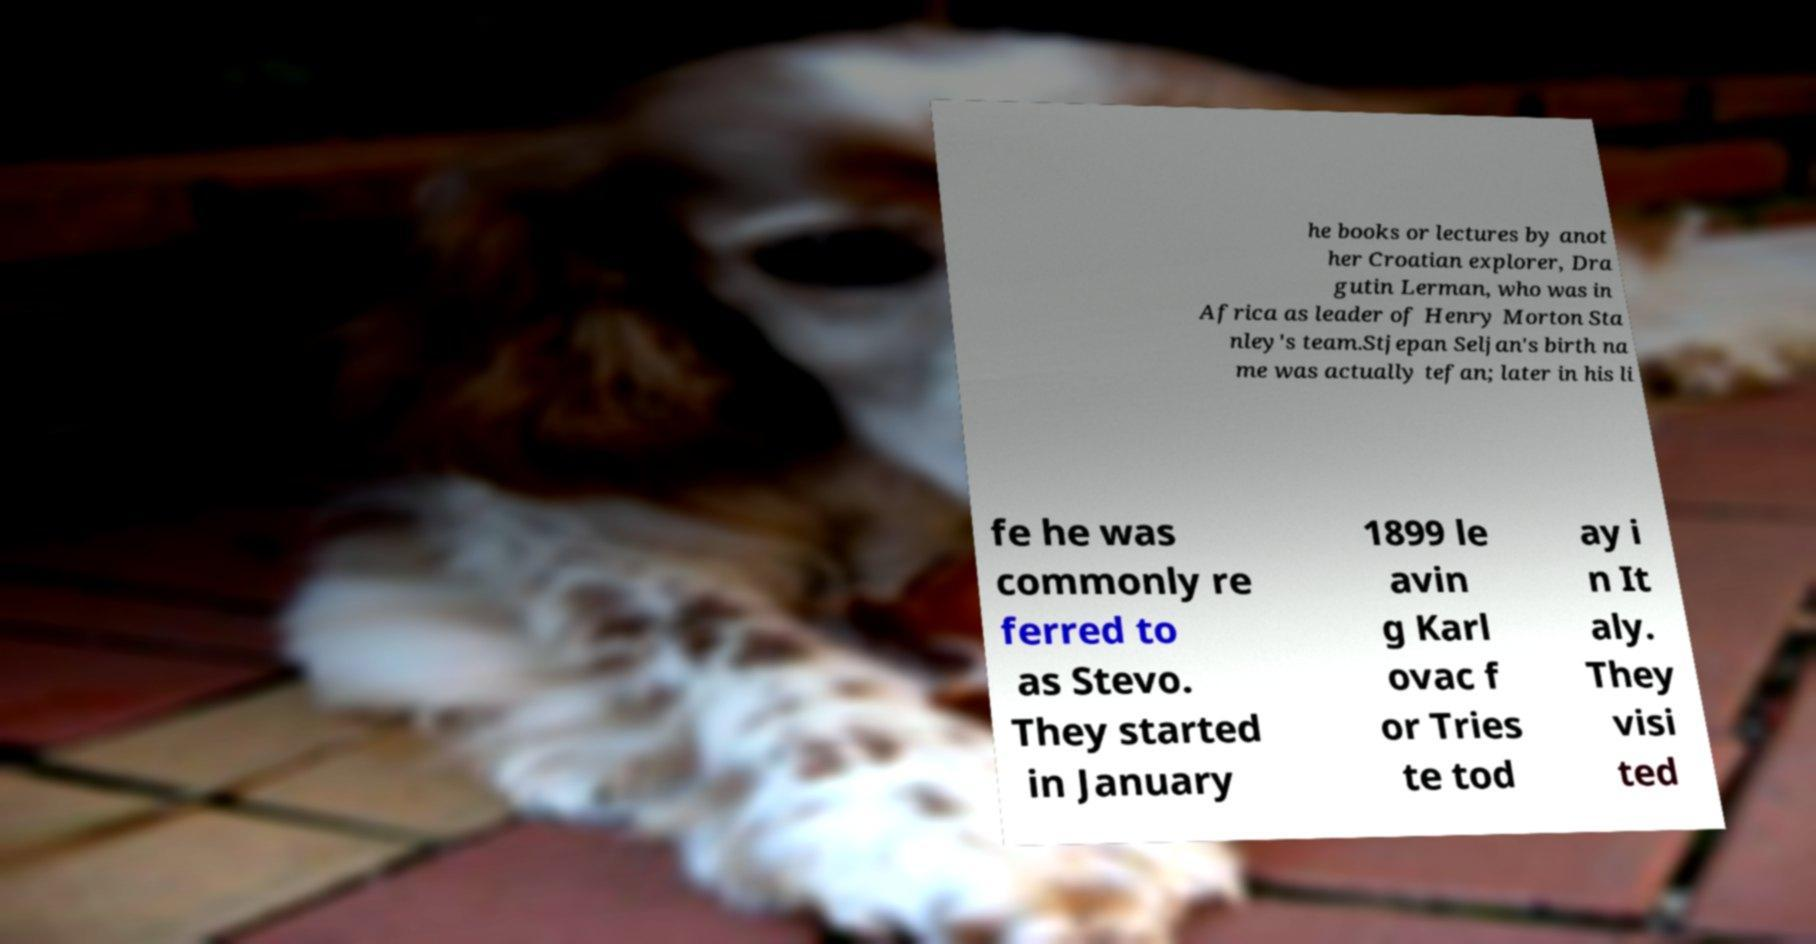Please read and relay the text visible in this image. What does it say? he books or lectures by anot her Croatian explorer, Dra gutin Lerman, who was in Africa as leader of Henry Morton Sta nley's team.Stjepan Seljan's birth na me was actually tefan; later in his li fe he was commonly re ferred to as Stevo. They started in January 1899 le avin g Karl ovac f or Tries te tod ay i n It aly. They visi ted 